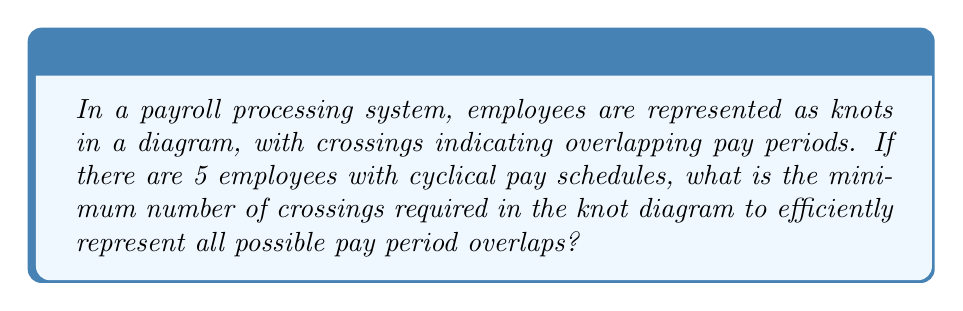Provide a solution to this math problem. To solve this problem, we need to apply concepts from knot theory to payroll processing:

1. Each employee represents a strand in the knot diagram.

2. The minimum number of crossings for n strands is given by the formula:

   $$\text{Min crossings} = \frac{(n-1)(n-2)}{2}$$

3. In this case, n = 5 (number of employees)

4. Substituting into the formula:
   
   $$\text{Min crossings} = \frac{(5-1)(5-2)}{2}$$

5. Simplify:
   
   $$\text{Min crossings} = \frac{(4)(3)}{2} = \frac{12}{2} = 6$$

Therefore, the minimum number of crossings required to efficiently represent all possible pay period overlaps for 5 employees is 6.

[asy]
unitsize(1cm);

pair[] points = {(0,0), (2,0), (4,0), (6,0), (8,0)};
pair[] ctrl1 = {(1,1), (3,1), (5,1), (7,1), (-1,1)};
pair[] ctrl2 = {(1,-1), (3,-1), (5,-1), (7,-1), (9,-1)};

for(int i=0; i<5; ++i) {
  draw(points[i]..ctrl1[i]..ctrl2[i]..points[(i+1)%5], black+1);
}

[/asy]
Answer: 6 crossings 